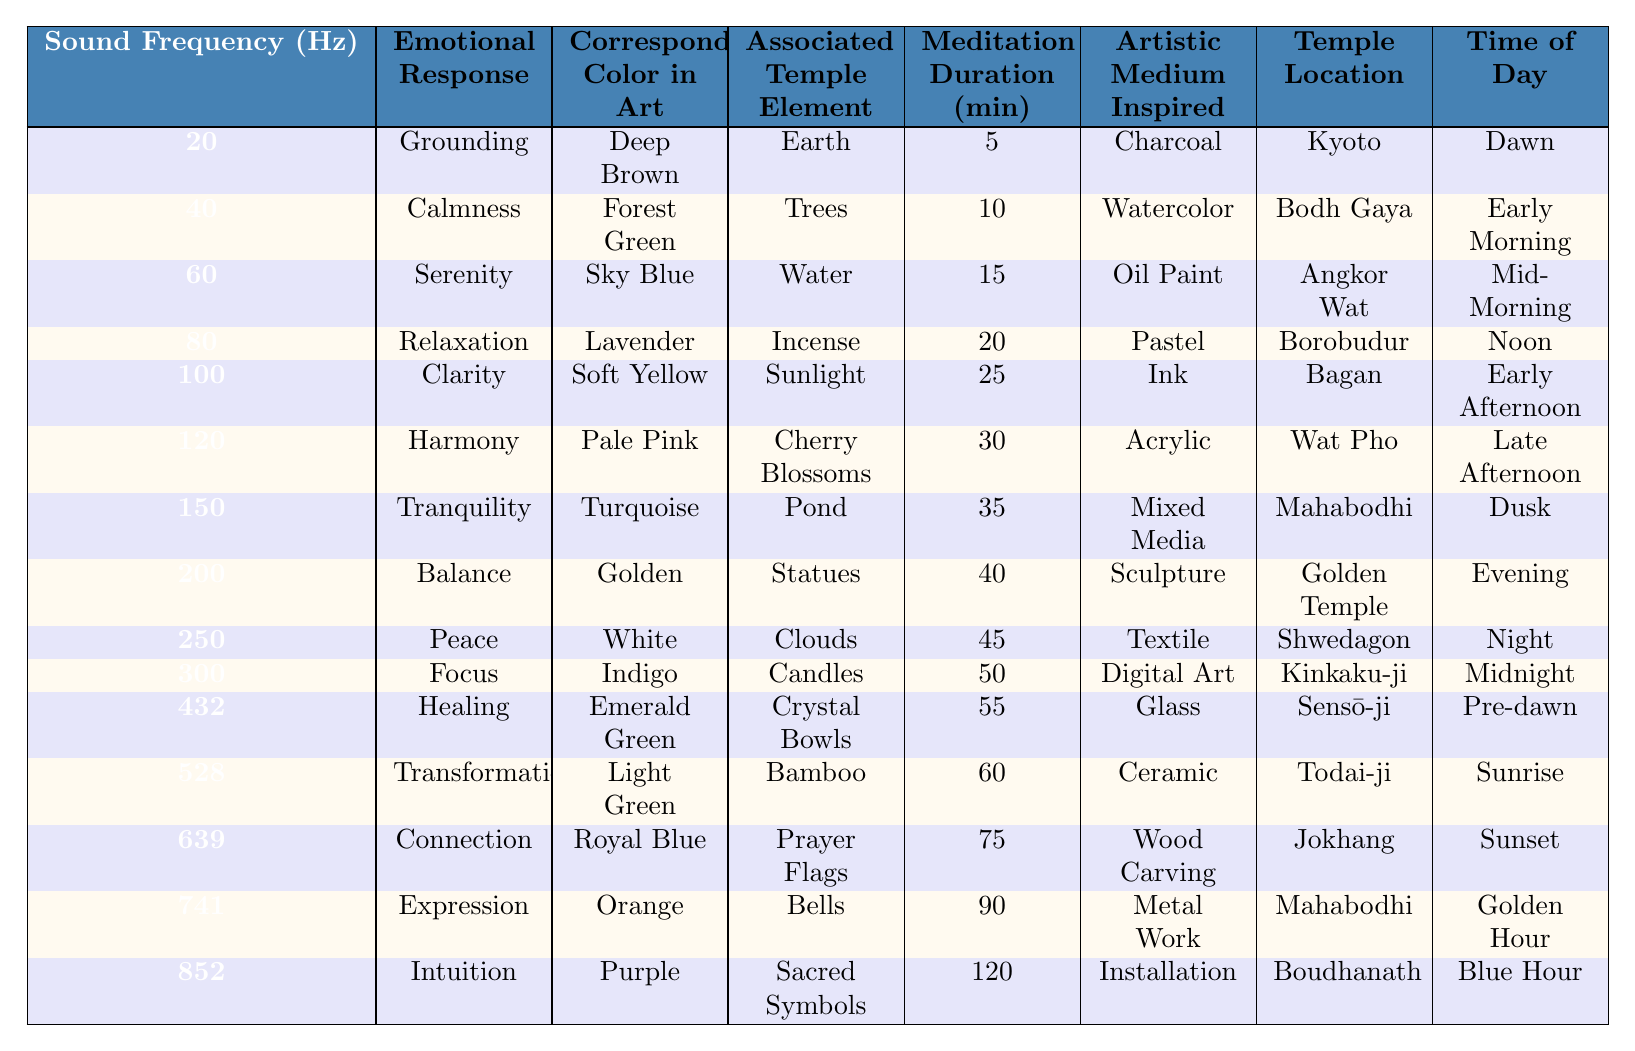What emotional response is associated with the sound frequency of 528 Hz? In the table, under the column for sound frequency, the row for 528 Hz lists the emotional response as "Transformation."
Answer: Transformation Which color corresponds to the emotional response of Tranquility? The table shows that the emotional response of Tranquility is associated with the color Turquoise.
Answer: Turquoise How many minutes should one meditate to experience Balance? Referring to the table, the duration of meditation associated with Balance is 40 minutes.
Answer: 40 Which artistic medium is inspired by the sound frequency of 200 Hz? The table indicates that the artistic medium inspired by the sound frequency of 200 Hz is Sculpture.
Answer: Sculpture What is the average meditation duration for all sound frequencies listed in the table? To find the average, we sum the meditation durations (5 + 10 + 15 + 20 + 25 + 30 + 35 + 40 + 45 + 50 + 55 + 60 + 75 + 90 + 120 = 525) and divide by the number of frequencies (15). Therefore, 525/15 = 35.
Answer: 35 Which emotional responses occur during the Early Morning? According to the table, during Early Morning, the emotional response is Calmness.
Answer: Calmness Is there a sound frequency associated with the color White? Yes, the table shows that the sound frequency of 250 Hz corresponds to the color White.
Answer: Yes What is the relationship between the emotional response of Healing and the associated temple element? In the table, the emotional response of Healing is associated with the temple element of Crystal Bowls.
Answer: Crystal Bowls Which temple location has the longest meditation duration and what is that duration? The longest meditation duration listed is 120 minutes, and it is associated with the temple location of Boudhanath.
Answer: Boudhanath, 120 minutes How does the emotional response of Intuition relate to the time of day when it occurs? Intuition is associated with the time of day referred to as Blue Hour according to the table.
Answer: Blue Hour 